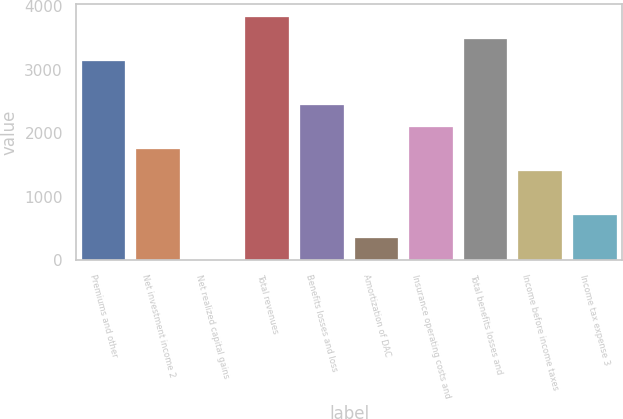Convert chart. <chart><loc_0><loc_0><loc_500><loc_500><bar_chart><fcel>Premiums and other<fcel>Net investment income 2<fcel>Net realized capital gains<fcel>Total revenues<fcel>Benefits losses and loss<fcel>Amortization of DAC<fcel>Insurance operating costs and<fcel>Total benefits losses and<fcel>Income before income taxes<fcel>Income tax expense 3<nl><fcel>3136<fcel>1753.5<fcel>11<fcel>3833<fcel>2450.5<fcel>359.5<fcel>2102<fcel>3484.5<fcel>1405<fcel>708<nl></chart> 